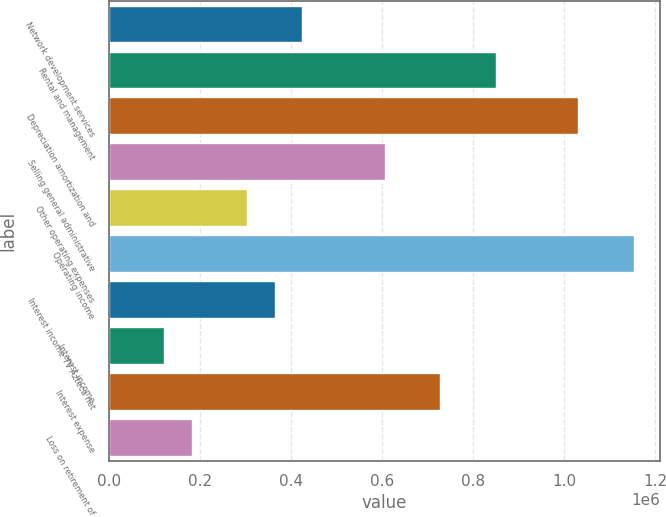Convert chart. <chart><loc_0><loc_0><loc_500><loc_500><bar_chart><fcel>Network development services<fcel>Rental and management<fcel>Depreciation amortization and<fcel>Selling general administrative<fcel>Other operating expenses<fcel>Operating income<fcel>Interest income TV Azteca net<fcel>Interest income<fcel>Interest expense<fcel>Loss on retirement of<nl><fcel>424734<fcel>849447<fcel>1.03147e+06<fcel>606754<fcel>303388<fcel>1.15281e+06<fcel>364061<fcel>121368<fcel>728100<fcel>182042<nl></chart> 